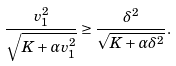<formula> <loc_0><loc_0><loc_500><loc_500>\frac { v _ { 1 } ^ { 2 } } { \sqrt { K + \alpha v _ { 1 } ^ { 2 } } } \geq \frac { \delta ^ { 2 } } { \sqrt { K + \alpha \delta ^ { 2 } } } .</formula> 